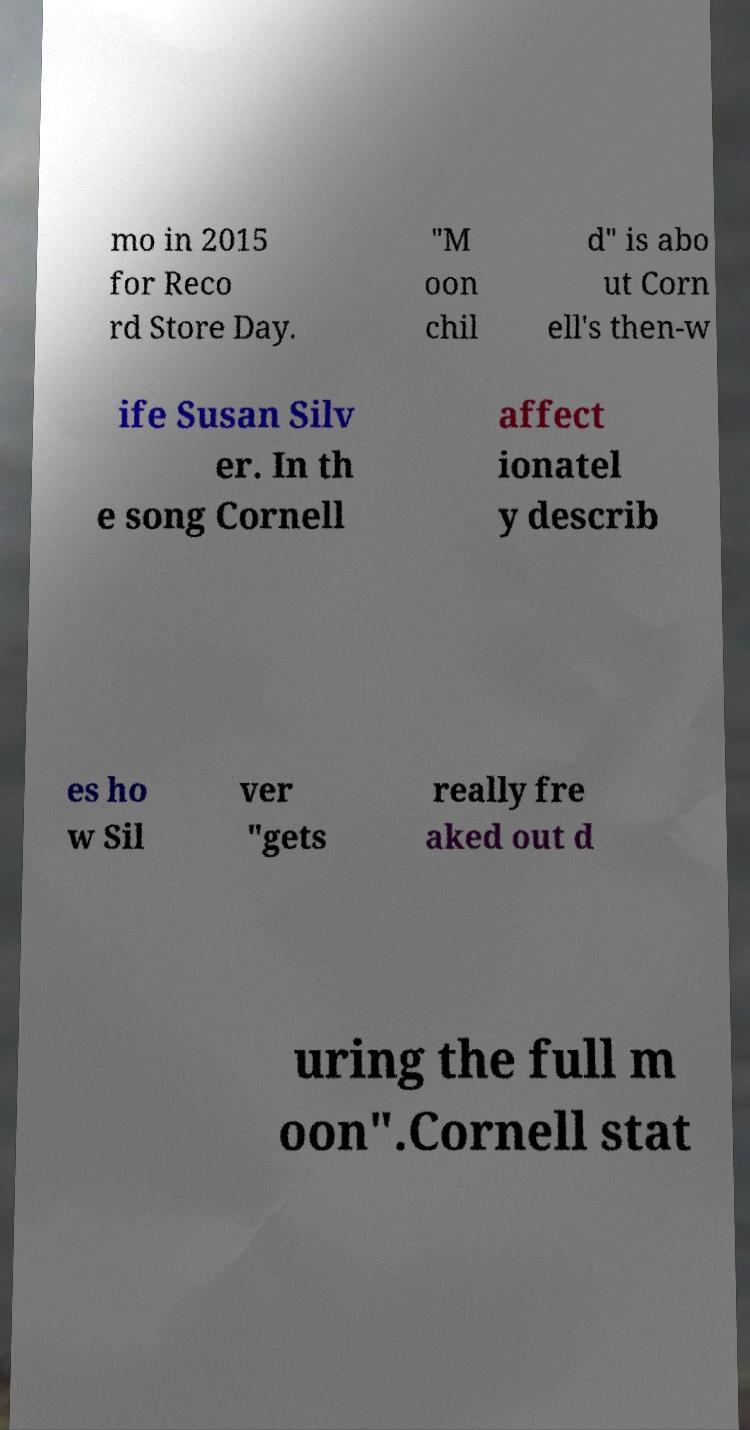What messages or text are displayed in this image? I need them in a readable, typed format. mo in 2015 for Reco rd Store Day. "M oon chil d" is abo ut Corn ell's then-w ife Susan Silv er. In th e song Cornell affect ionatel y describ es ho w Sil ver "gets really fre aked out d uring the full m oon".Cornell stat 